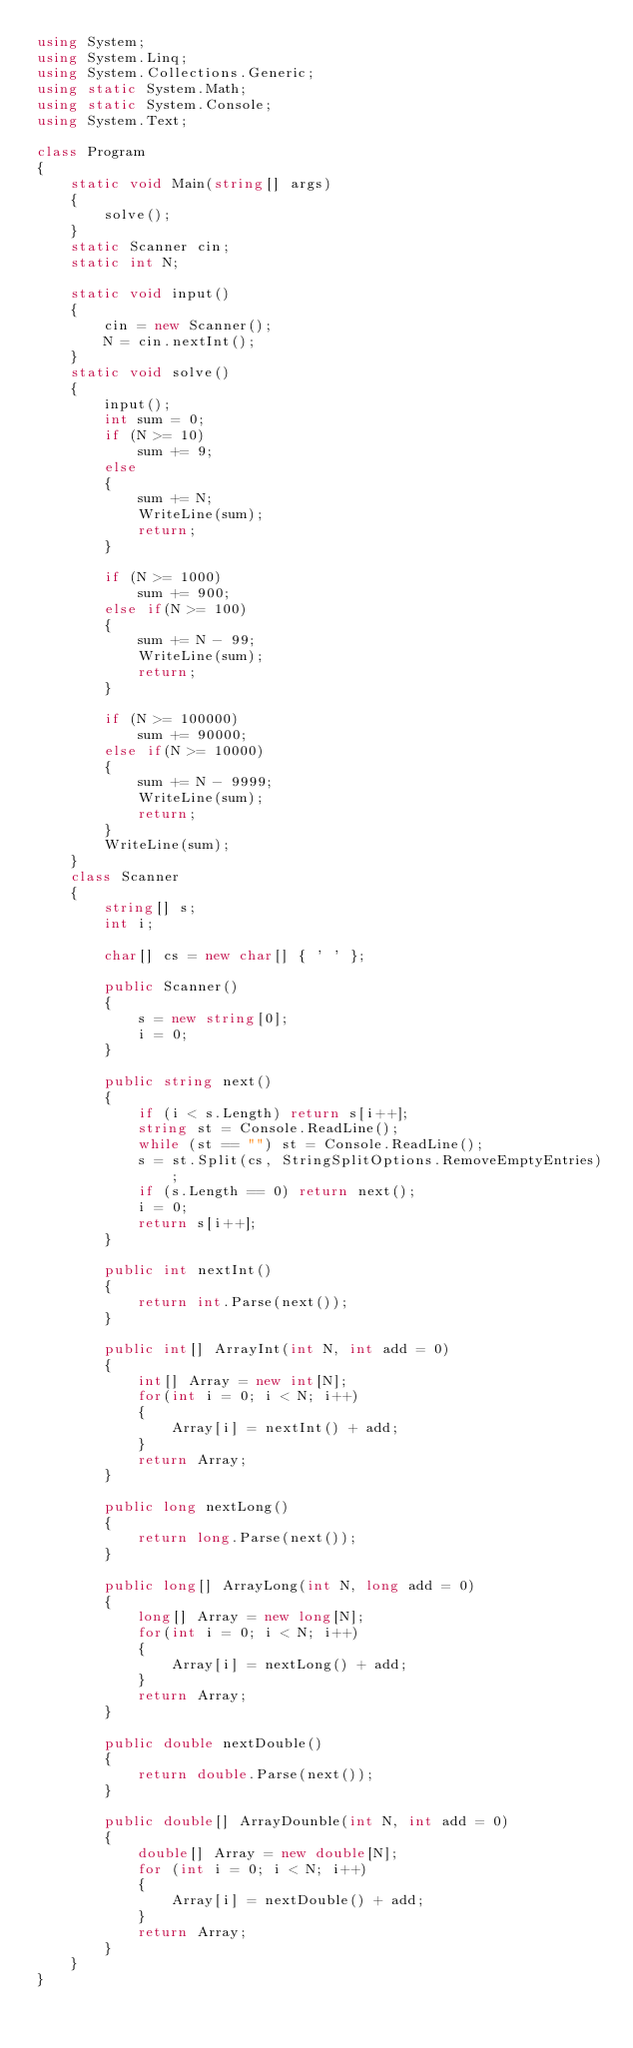Convert code to text. <code><loc_0><loc_0><loc_500><loc_500><_C#_>using System;
using System.Linq;
using System.Collections.Generic;
using static System.Math;
using static System.Console;
using System.Text;

class Program
{
    static void Main(string[] args)
    {
        solve();
    }
    static Scanner cin;
    static int N;

    static void input()
    {
        cin = new Scanner();
        N = cin.nextInt();
    }
    static void solve()
    {
        input();
        int sum = 0;
        if (N >= 10)
            sum += 9;
        else
        {
            sum += N;
            WriteLine(sum);
            return;
        }

        if (N >= 1000)
            sum += 900;
        else if(N >= 100)
        {
            sum += N - 99;
            WriteLine(sum);
            return;
        }

        if (N >= 100000)
            sum += 90000;
        else if(N >= 10000)
        {
            sum += N - 9999;
            WriteLine(sum);
            return;
        }
        WriteLine(sum);
    }
    class Scanner
    {
        string[] s;
        int i;

        char[] cs = new char[] { ' ' };

        public Scanner()
        {
            s = new string[0];
            i = 0;
        }
        
        public string next()
        {
            if (i < s.Length) return s[i++];
            string st = Console.ReadLine();
            while (st == "") st = Console.ReadLine();
            s = st.Split(cs, StringSplitOptions.RemoveEmptyEntries);
            if (s.Length == 0) return next();
            i = 0;
            return s[i++];
        }

        public int nextInt()
        {
            return int.Parse(next());
        }

        public int[] ArrayInt(int N, int add = 0)
        {
            int[] Array = new int[N];
            for(int i = 0; i < N; i++)
            {
                Array[i] = nextInt() + add;
            }
            return Array;
        }

        public long nextLong()
        {
            return long.Parse(next());
        }

        public long[] ArrayLong(int N, long add = 0)
        {
            long[] Array = new long[N];
            for(int i = 0; i < N; i++)
            {
                Array[i] = nextLong() + add;
            }
            return Array;
        }

        public double nextDouble()
        {
            return double.Parse(next());
        }

        public double[] ArrayDounble(int N, int add = 0)
        {
            double[] Array = new double[N];
            for (int i = 0; i < N; i++)
            {
                Array[i] = nextDouble() + add;
            }
            return Array;
        }
    }
}</code> 